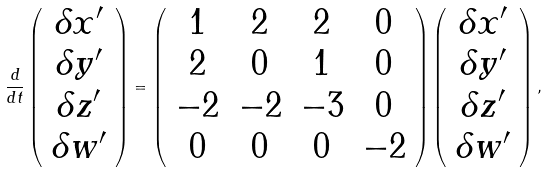<formula> <loc_0><loc_0><loc_500><loc_500>\frac { d } { d t } \left ( \begin{array} { c } \delta x ^ { \prime } \\ \delta y ^ { \prime } \\ \delta z ^ { \prime } \\ \delta w ^ { \prime } \end{array} \right ) = \left ( \begin{array} { c c c c } 1 & 2 & 2 & 0 \\ 2 & 0 & 1 & 0 \\ - 2 & - 2 & - 3 & 0 \\ 0 & 0 & 0 & - 2 \end{array} \right ) \left ( \begin{array} { c } \delta x ^ { \prime } \\ \delta y ^ { \prime } \\ \delta z ^ { \prime } \\ \delta w ^ { \prime } \end{array} \right ) ,</formula> 